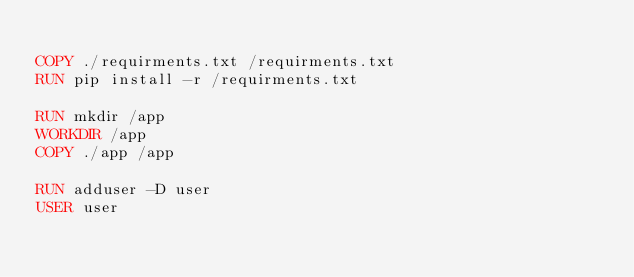Convert code to text. <code><loc_0><loc_0><loc_500><loc_500><_Dockerfile_>
COPY ./requirments.txt /requirments.txt
RUN pip install -r /requirments.txt

RUN mkdir /app
WORKDIR /app
COPY ./app /app

RUN adduser -D user
USER user
</code> 